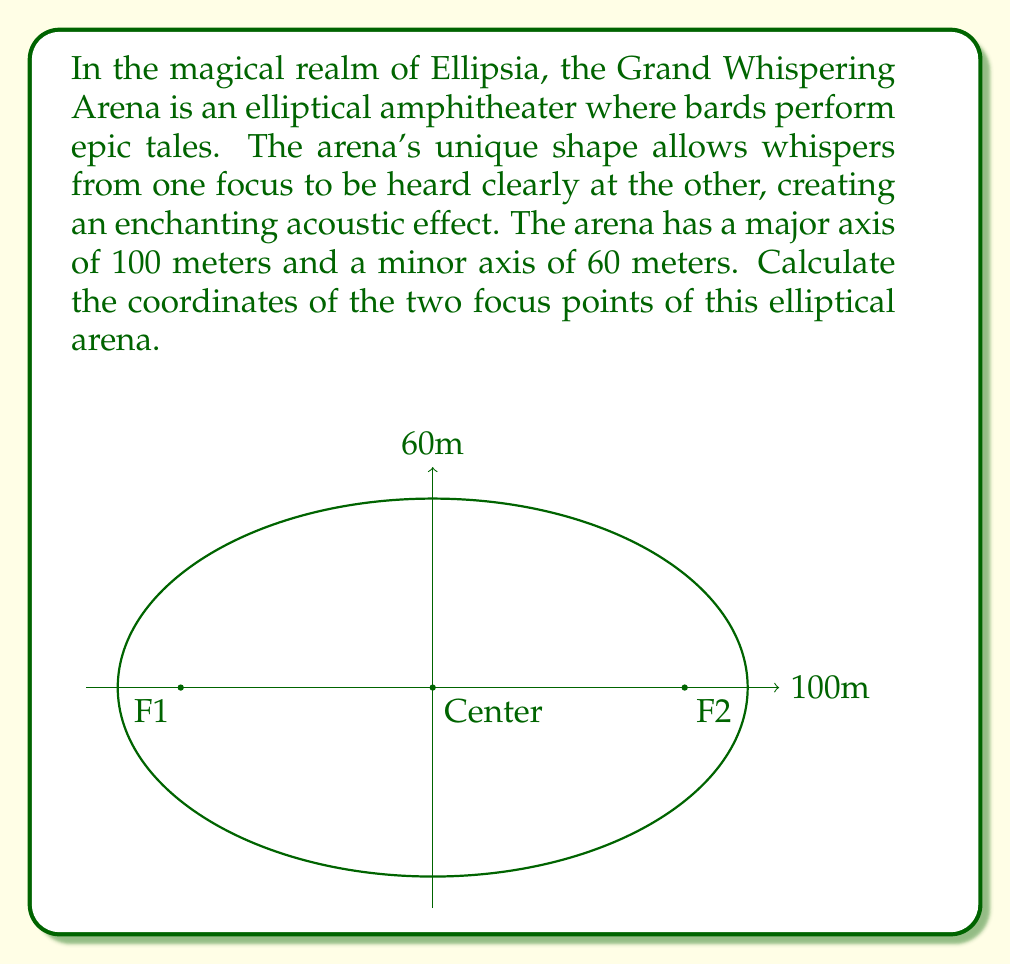Show me your answer to this math problem. Let's solve this step-by-step:

1) The equation of an ellipse centered at the origin is:

   $$\frac{x^2}{a^2} + \frac{y^2}{b^2} = 1$$

   where $a$ is half the major axis and $b$ is half the minor axis.

2) In this case:
   $a = 50$ meters (half of 100m)
   $b = 30$ meters (half of 60m)

3) The distance from the center to a focus, let's call it $c$, is given by the formula:

   $$c^2 = a^2 - b^2$$

4) Substituting our values:

   $$c^2 = 50^2 - 30^2 = 2500 - 900 = 1600$$

5) Taking the square root:

   $$c = \sqrt{1600} = 40$$

6) The foci are located on the major axis, equidistant from the center. Their coordinates will be:

   $F_1 = (-40, 0)$ and $F_2 = (40, 0)$

Thus, the magical focus points of the Grand Whispering Arena are 40 meters to the left and right of the center on the major axis.
Answer: $F_1 = (-40, 0)$, $F_2 = (40, 0)$ 